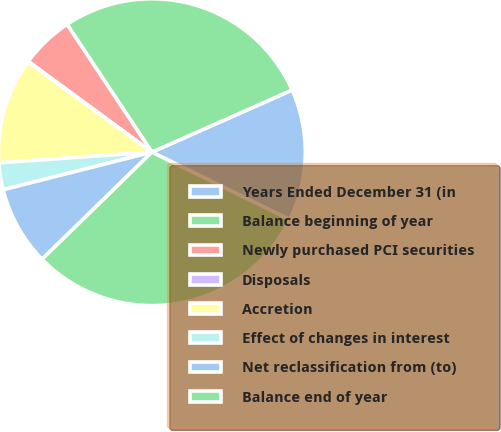Convert chart to OTSL. <chart><loc_0><loc_0><loc_500><loc_500><pie_chart><fcel>Years Ended December 31 (in<fcel>Balance beginning of year<fcel>Newly purchased PCI securities<fcel>Disposals<fcel>Accretion<fcel>Effect of changes in interest<fcel>Net reclassification from (to)<fcel>Balance end of year<nl><fcel>13.88%<fcel>27.69%<fcel>5.59%<fcel>0.07%<fcel>11.12%<fcel>2.83%<fcel>8.36%<fcel>30.46%<nl></chart> 